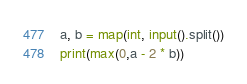<code> <loc_0><loc_0><loc_500><loc_500><_Python_>a, b = map(int, input().split())
print(max(0,a - 2 * b))</code> 